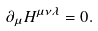<formula> <loc_0><loc_0><loc_500><loc_500>\partial _ { \mu } H ^ { \mu \nu \lambda } = 0 .</formula> 